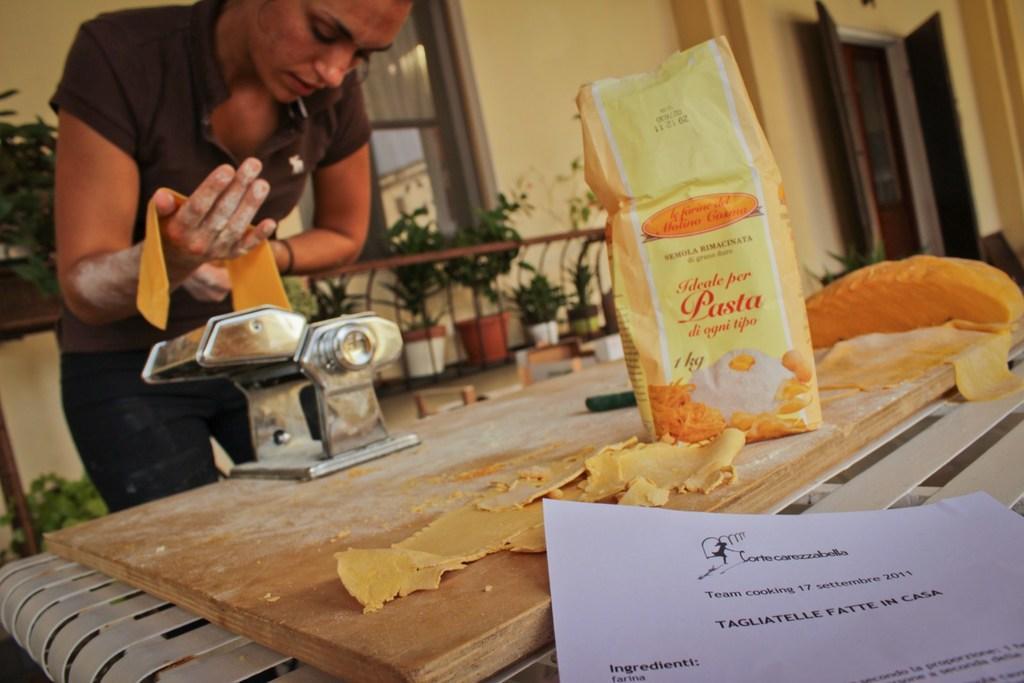In one or two sentences, can you explain what this image depicts? In the picture we can see a woman standing and bending and holding some pasta wheat and pouring into the machine on the wooden plank and besides to it, we can see some pasta packet, and in the background, we can see the railing behind it we can see some house plants, building wall with windows. 